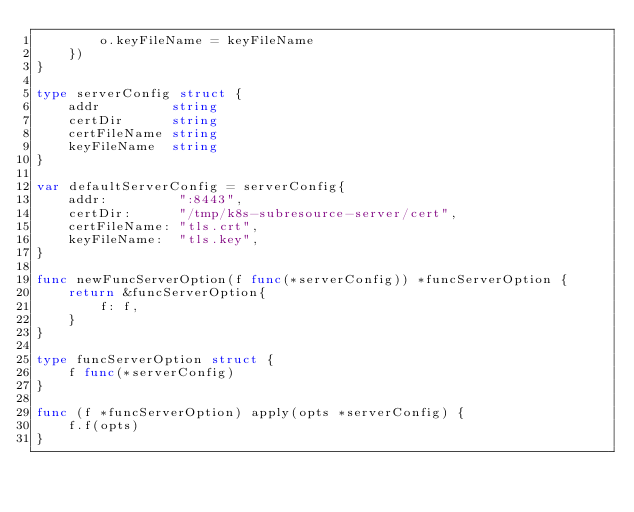Convert code to text. <code><loc_0><loc_0><loc_500><loc_500><_Go_>		o.keyFileName = keyFileName
	})
}

type serverConfig struct {
	addr         string
	certDir      string
	certFileName string
	keyFileName  string
}

var defaultServerConfig = serverConfig{
	addr:         ":8443",
	certDir:      "/tmp/k8s-subresource-server/cert",
	certFileName: "tls.crt",
	keyFileName:  "tls.key",
}

func newFuncServerOption(f func(*serverConfig)) *funcServerOption {
	return &funcServerOption{
		f: f,
	}
}

type funcServerOption struct {
	f func(*serverConfig)
}

func (f *funcServerOption) apply(opts *serverConfig) {
	f.f(opts)
}
</code> 